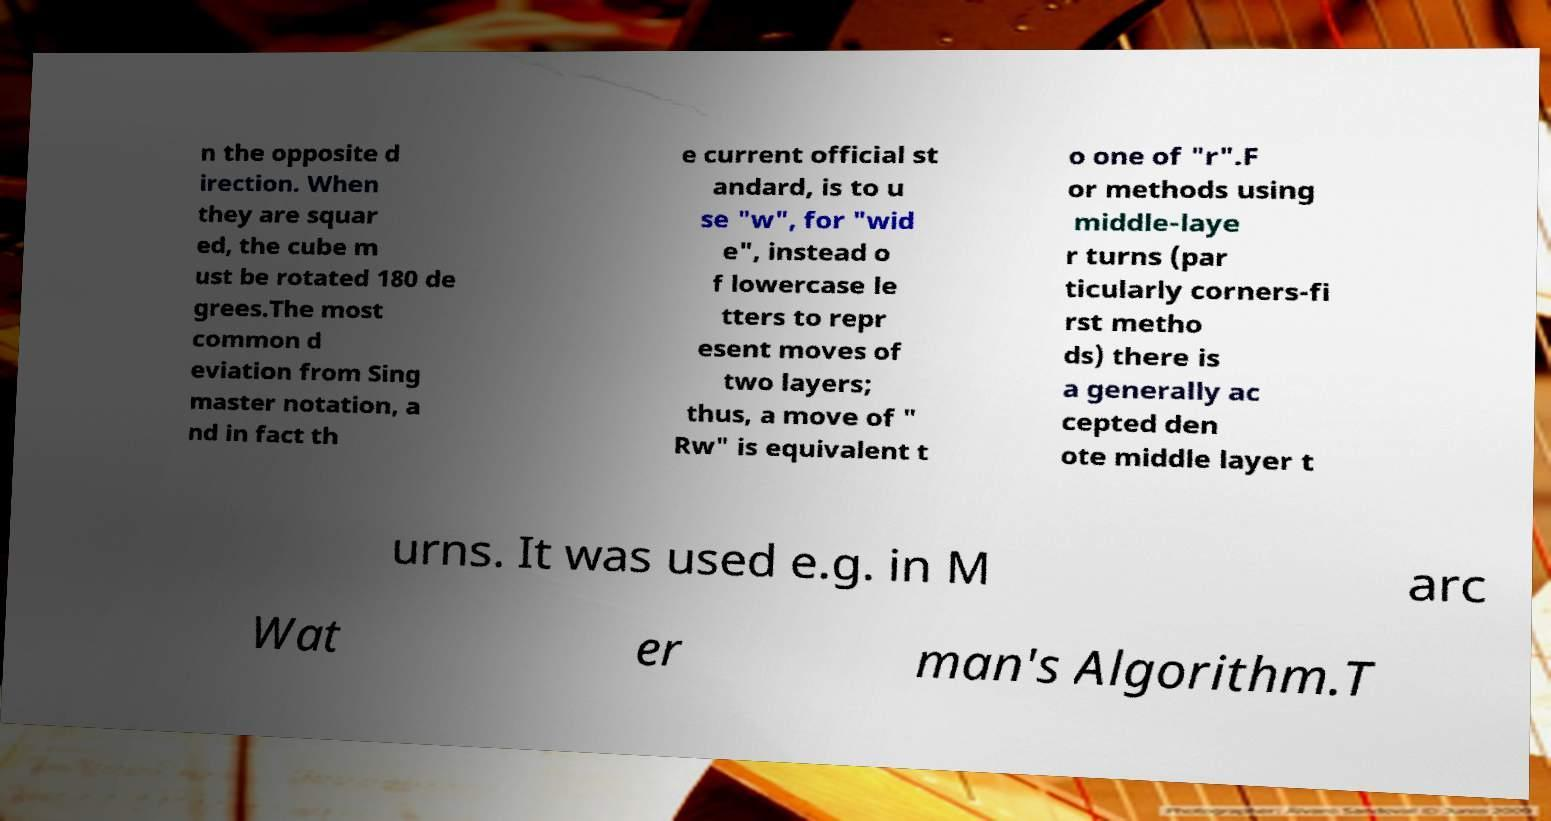Please identify and transcribe the text found in this image. n the opposite d irection. When they are squar ed, the cube m ust be rotated 180 de grees.The most common d eviation from Sing master notation, a nd in fact th e current official st andard, is to u se "w", for "wid e", instead o f lowercase le tters to repr esent moves of two layers; thus, a move of " Rw" is equivalent t o one of "r".F or methods using middle-laye r turns (par ticularly corners-fi rst metho ds) there is a generally ac cepted den ote middle layer t urns. It was used e.g. in M arc Wat er man's Algorithm.T 